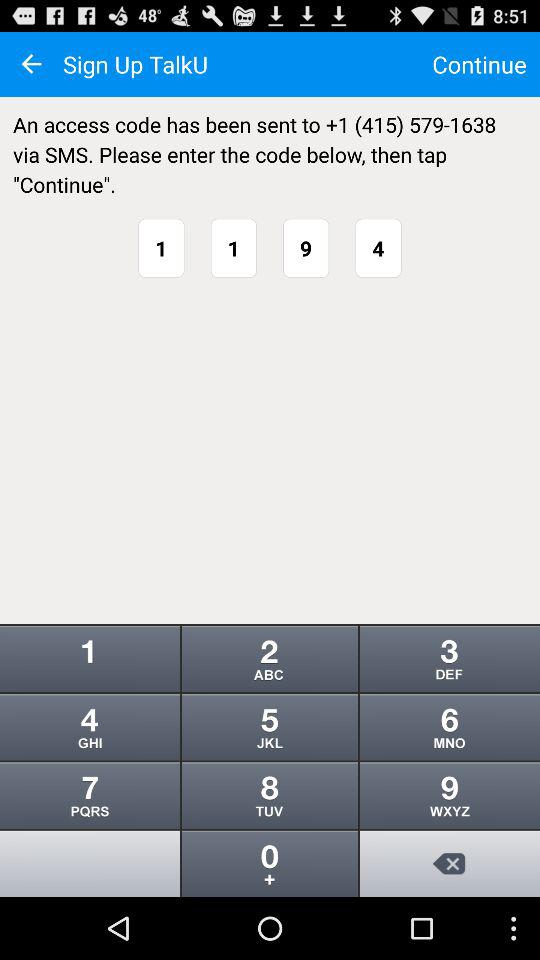What is the code? The code is 1194. 